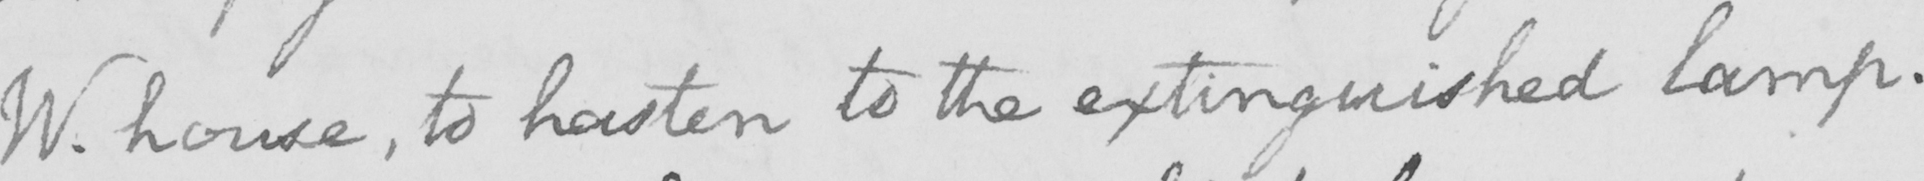What is written in this line of handwriting? W . house , to hasten to the extinguished lamp . 